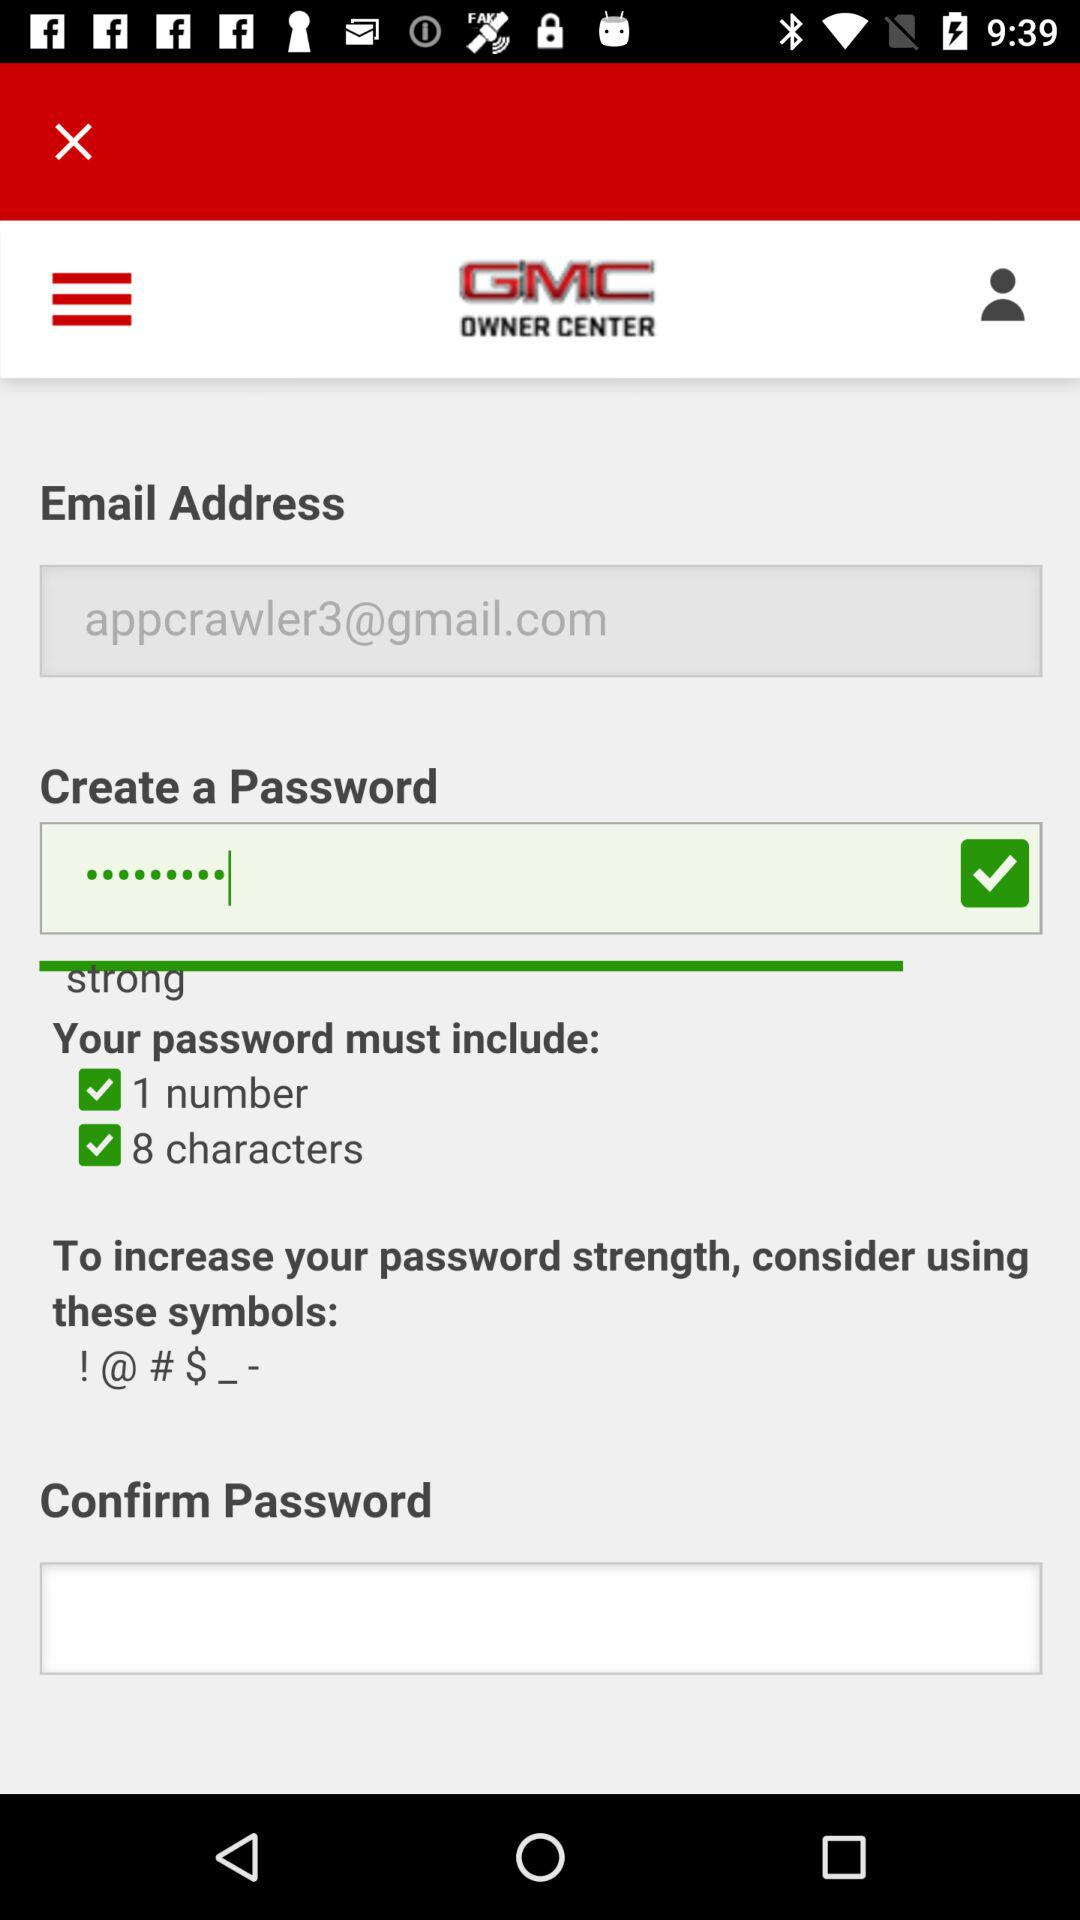How to increase the password strength? To increase the password strength, "consider using these symbols:! @ # $ _ -". 